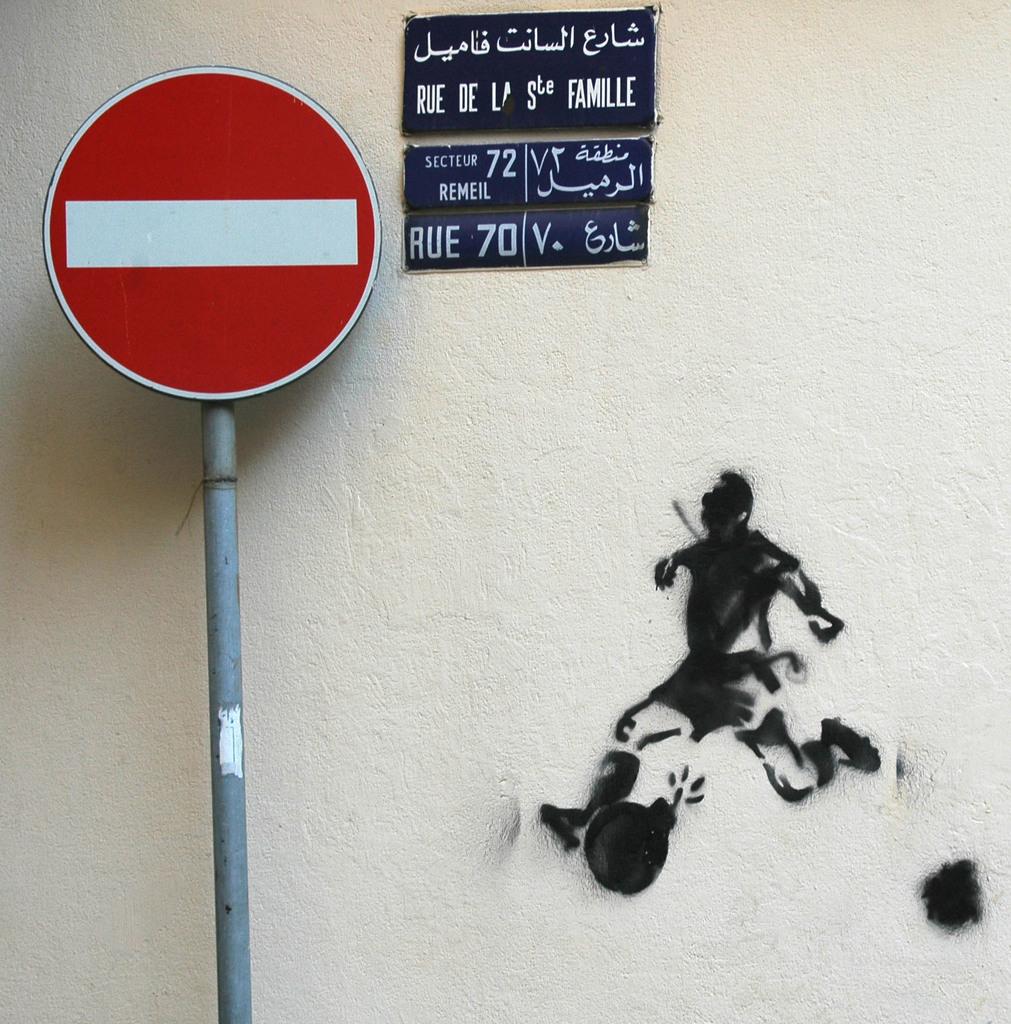What number is beside rue?
Give a very brief answer. 70. 